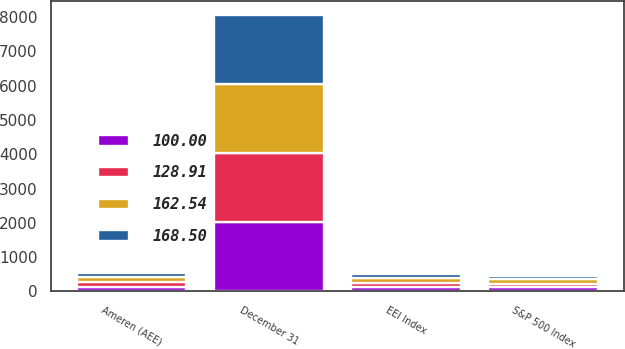Convert chart. <chart><loc_0><loc_0><loc_500><loc_500><stacked_bar_chart><ecel><fcel>December 31<fcel>Ameren (AEE)<fcel>S&P 500 Index<fcel>EEI Index<nl><fcel>168.5<fcel>2013<fcel>100<fcel>100<fcel>100<nl><fcel>128.91<fcel>2014<fcel>132.73<fcel>113.69<fcel>128.91<nl><fcel>100<fcel>2015<fcel>129.58<fcel>115.26<fcel>123.88<nl><fcel>162.54<fcel>2016<fcel>162.84<fcel>129.04<fcel>145.49<nl></chart> 